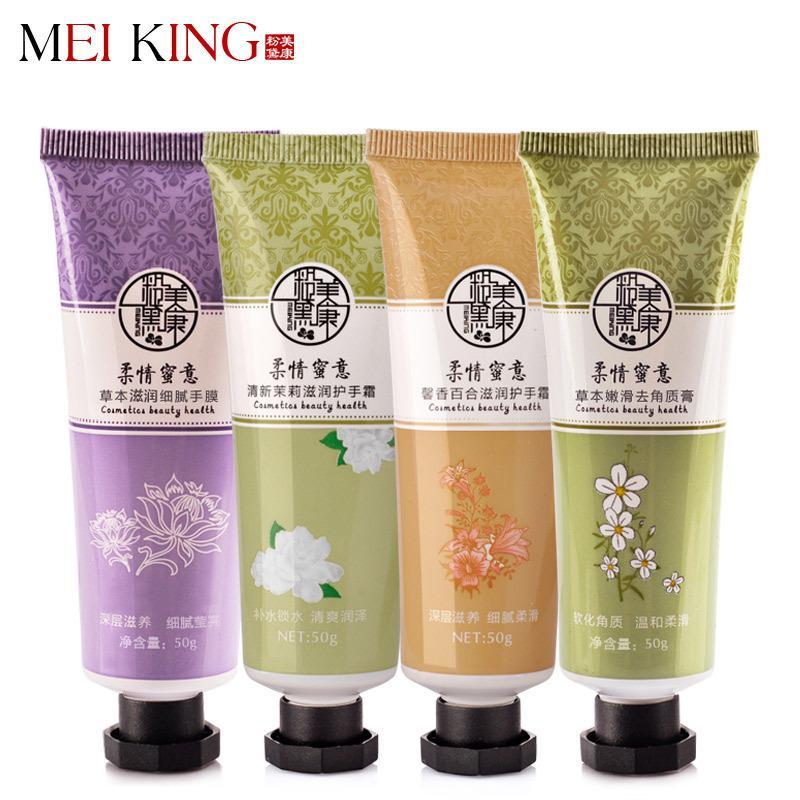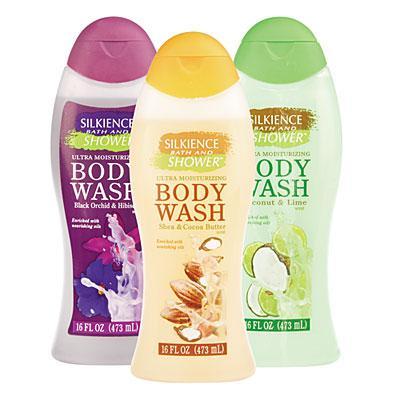The first image is the image on the left, the second image is the image on the right. For the images shown, is this caption "A box and a tube of whitening cream are in one image." true? Answer yes or no. No. 